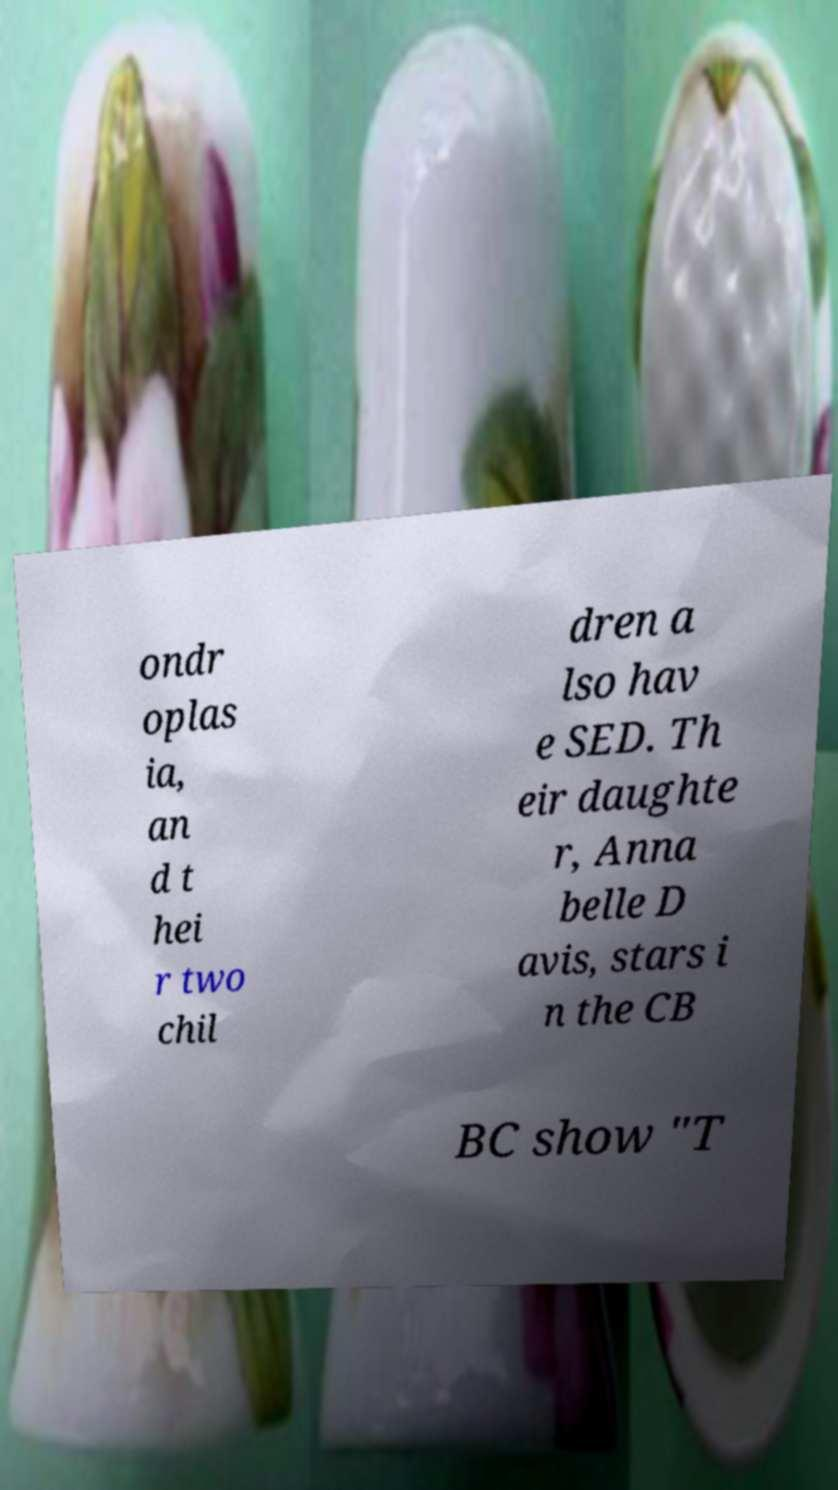Please read and relay the text visible in this image. What does it say? ondr oplas ia, an d t hei r two chil dren a lso hav e SED. Th eir daughte r, Anna belle D avis, stars i n the CB BC show "T 